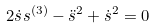<formula> <loc_0><loc_0><loc_500><loc_500>2 \dot { s } s ^ { ( 3 ) } - \ddot { s } ^ { 2 } + \dot { s } ^ { 2 } = 0</formula> 